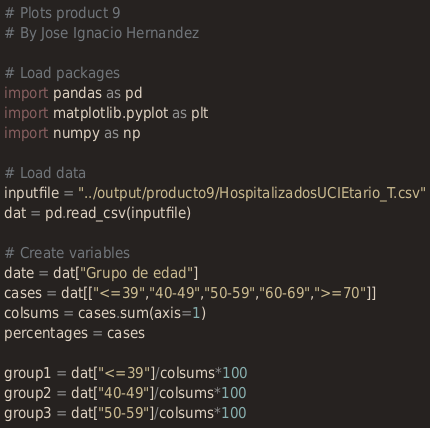Convert code to text. <code><loc_0><loc_0><loc_500><loc_500><_Python_># Plots product 9
# By Jose Ignacio Hernandez

# Load packages
import pandas as pd
import matplotlib.pyplot as plt
import numpy as np

# Load data
inputfile = "../output/producto9/HospitalizadosUCIEtario_T.csv"
dat = pd.read_csv(inputfile)

# Create variables
date = dat["Grupo de edad"]
cases = dat[["<=39","40-49","50-59","60-69",">=70"]]
colsums = cases.sum(axis=1)
percentages = cases

group1 = dat["<=39"]/colsums*100
group2 = dat["40-49"]/colsums*100
group3 = dat["50-59"]/colsums*100</code> 